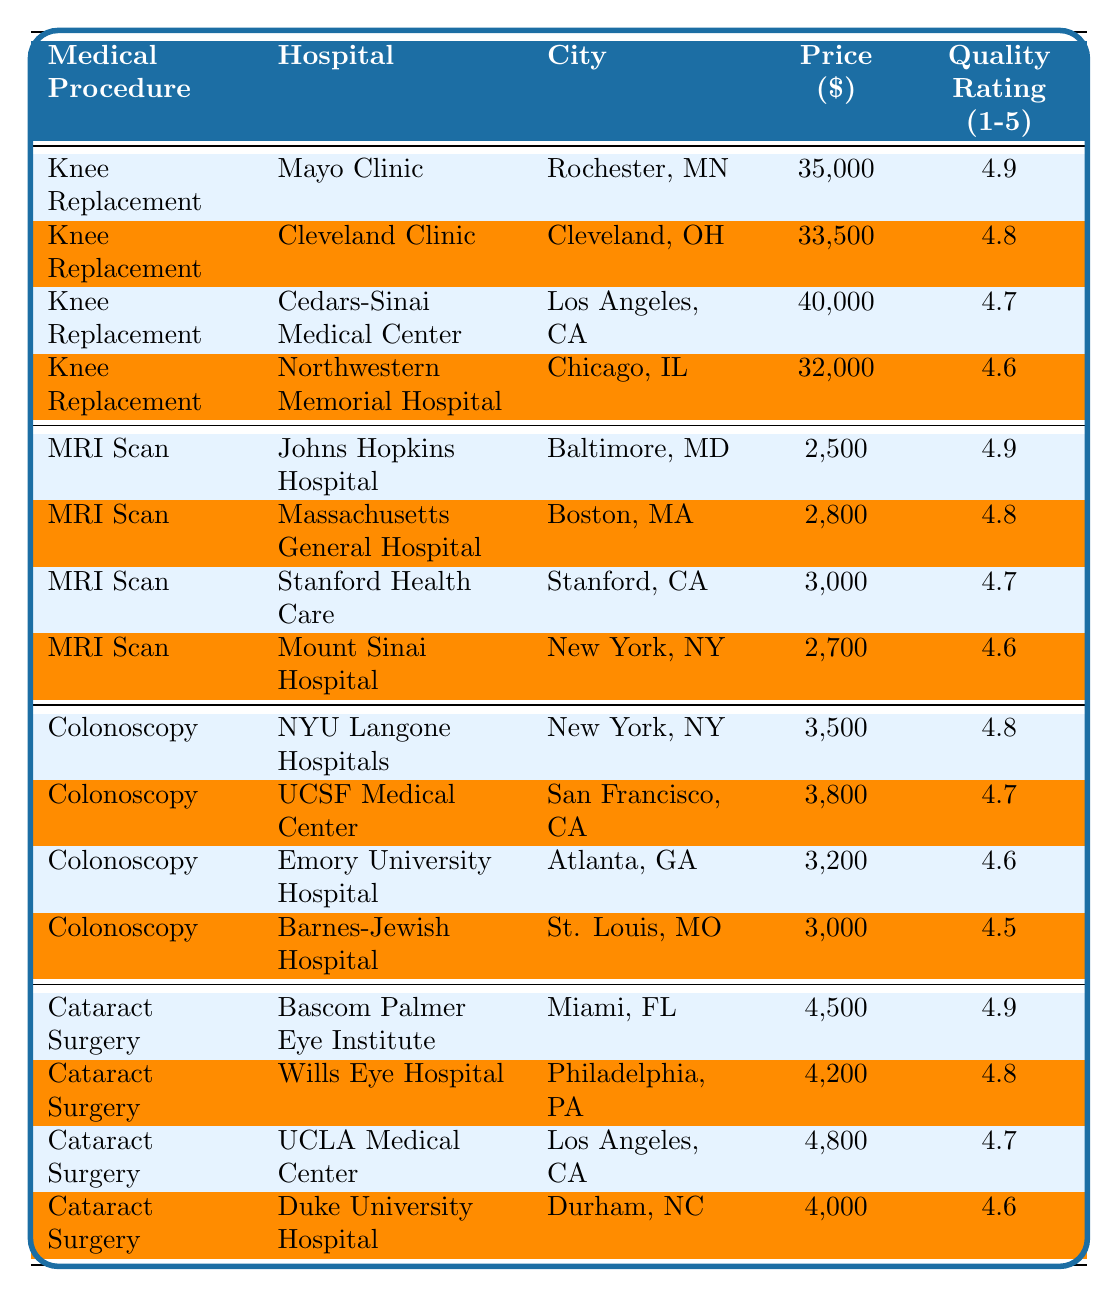What is the cheapest option for a Knee Replacement? The table lists the prices for Knee Replacement at different hospitals. The lowest price is at Northwestern Memorial Hospital, which is $32,000.
Answer: $32,000 Which hospital offers the highest quality rating for an MRI Scan? The quality ratings for MRI Scans are provided. Johns Hopkins Hospital has the highest quality rating of 4.9.
Answer: Johns Hopkins Hospital What is the average price of a Cataract Surgery? The prices for Cataract Surgery are 4,500, 4,200, 4,800, and 4,000. Sum them up: 4,500 + 4,200 + 4,800 + 4,000 = 17,500. There are 4 data points, so the average price is 17,500 / 4 = 4,375.
Answer: $4,375 Is the price for a Colonoscopy at NYU Langone Hospitals higher than at Barnes-Jewish Hospital? The price for Colonoscopy at NYU Langone Hospitals is $3,500 and at Barnes-Jewish Hospital is $3,000. Since 3,500 is greater than 3,000, the answer is yes.
Answer: Yes Which medical procedure has the highest rated hospital in terms of quality? The quality ratings are assessed for all medical procedures. The highest quality rating is 4.9 for both the Knee Replacement at Mayo Clinic and the MRI Scan at Johns Hopkins Hospital.
Answer: Knee Replacement & MRI Scan What is the difference in price for an MRI Scan between Johns Hopkins Hospital and Stanford Health Care? The price of an MRI Scan at Johns Hopkins Hospital is $2,500, and at Stanford Health Care, it is $3,000. To find the difference, subtract $2,500 from $3,000, which gives $500.
Answer: $500 Which city has a hospital with the lowest price for a Colonoscopy? The hospitals in the table list four locations for Colonoscopy with the lowest price being $3,000 at Barnes-Jewish Hospital in St. Louis, MO.
Answer: St. Louis, MO If a patient has a Knee Replacement at Cleveland Clinic, what quality rating can they expect? The quality rating for Knee Replacement at Cleveland Clinic is listed as 4.8.
Answer: 4.8 What is the total price for Cataract Surgery across all listed hospitals? The prices for Cataract Surgery are $4,500, $4,200, $4,800, and $4,000. Adding these together gives a total of $4,500 + $4,200 + $4,800 + $4,000 = $17,500.
Answer: $17,500 Is the price of an MRI Scan at Mount Sinai Hospital less than $3,000? The table indicates that the price for an MRI Scan at Mount Sinai Hospital is $2,700. Since $2,700 is less than $3,000, the answer is yes.
Answer: Yes 